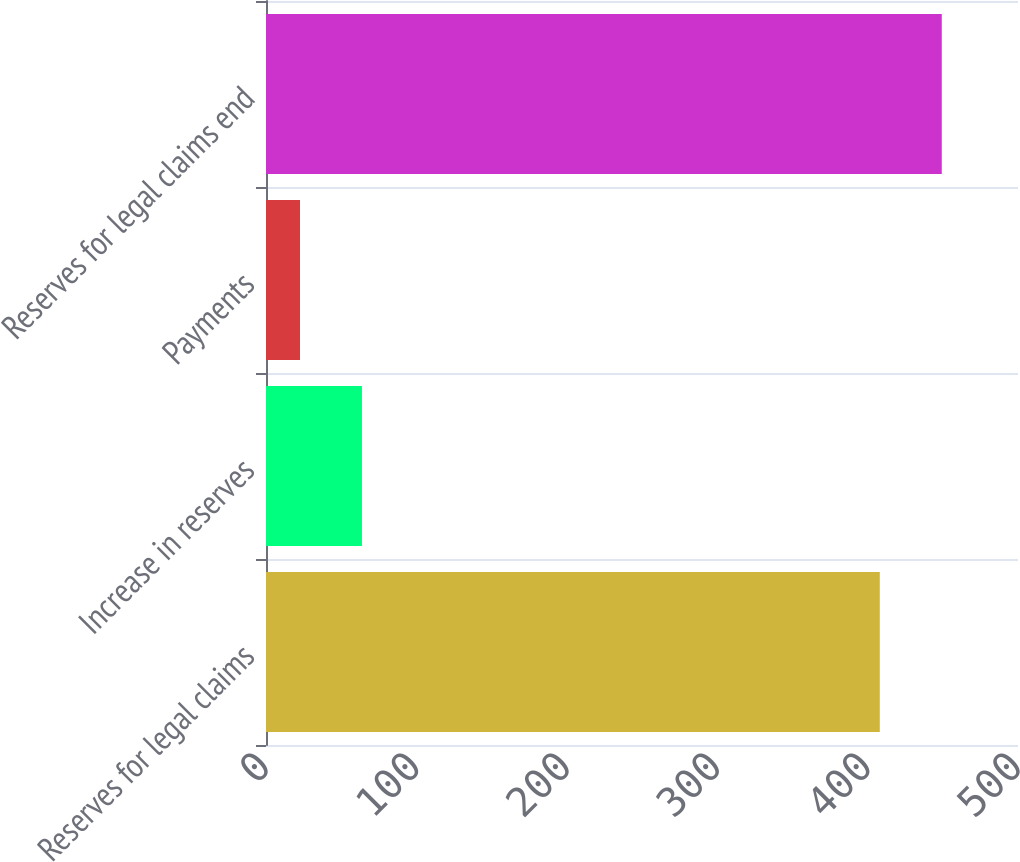Convert chart to OTSL. <chart><loc_0><loc_0><loc_500><loc_500><bar_chart><fcel>Reserves for legal claims<fcel>Increase in reserves<fcel>Payments<fcel>Reserves for legal claims end<nl><fcel>408.1<fcel>63.81<fcel>22.6<fcel>449.31<nl></chart> 